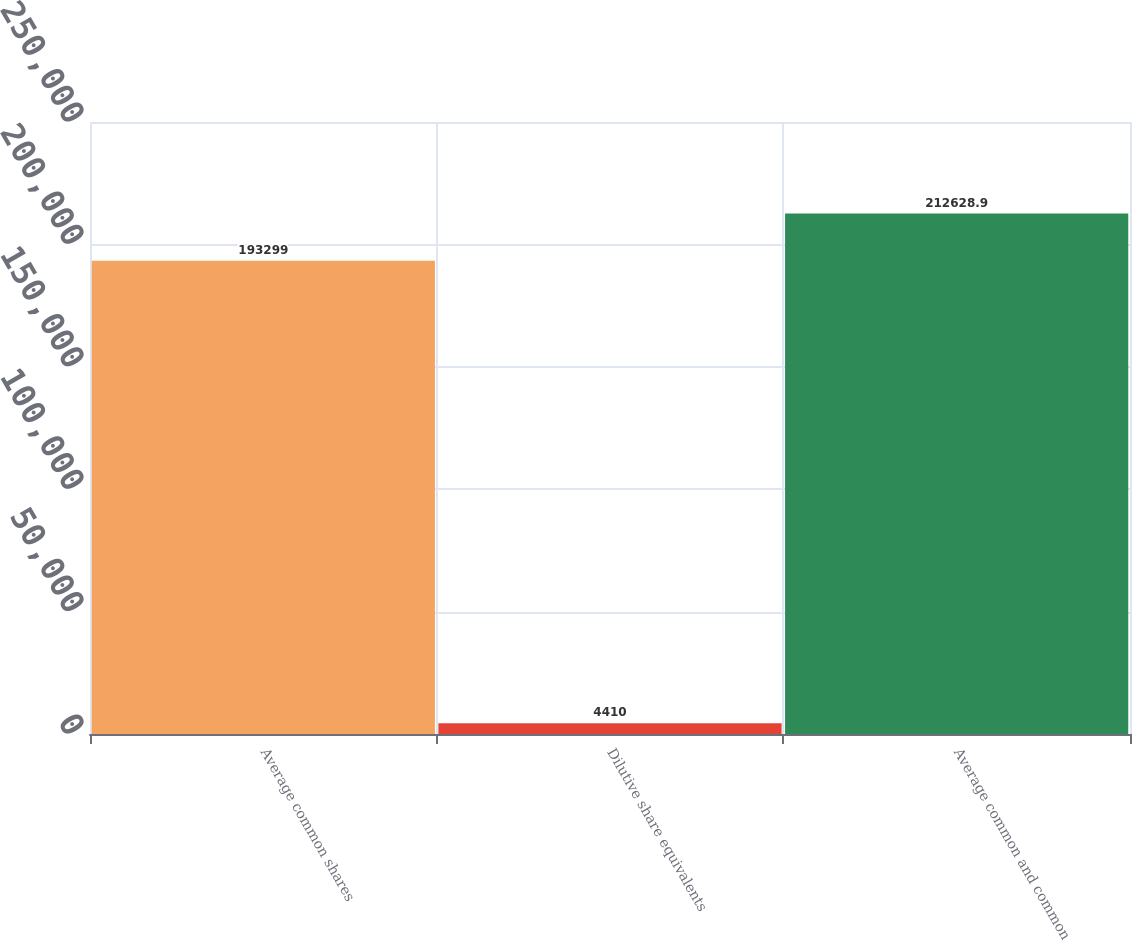Convert chart. <chart><loc_0><loc_0><loc_500><loc_500><bar_chart><fcel>Average common shares<fcel>Dilutive share equivalents<fcel>Average common and common<nl><fcel>193299<fcel>4410<fcel>212629<nl></chart> 